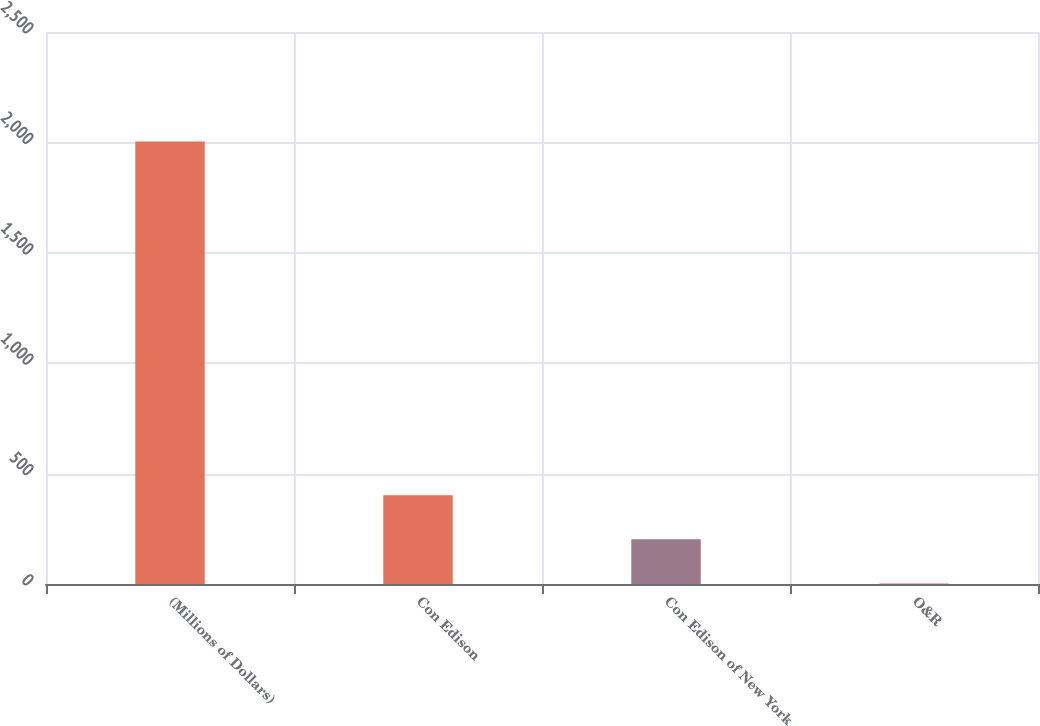<chart> <loc_0><loc_0><loc_500><loc_500><bar_chart><fcel>(Millions of Dollars)<fcel>Con Edison<fcel>Con Edison of New York<fcel>O&R<nl><fcel>2004<fcel>402.4<fcel>202.2<fcel>2<nl></chart> 